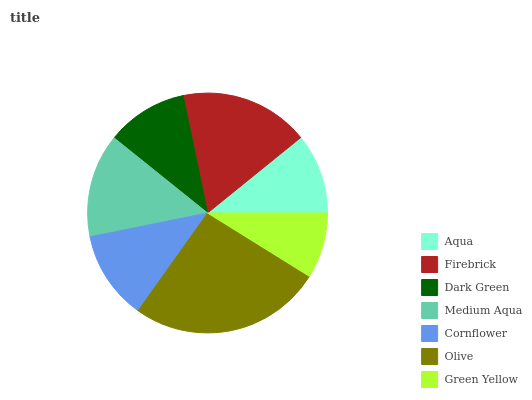Is Green Yellow the minimum?
Answer yes or no. Yes. Is Olive the maximum?
Answer yes or no. Yes. Is Firebrick the minimum?
Answer yes or no. No. Is Firebrick the maximum?
Answer yes or no. No. Is Firebrick greater than Aqua?
Answer yes or no. Yes. Is Aqua less than Firebrick?
Answer yes or no. Yes. Is Aqua greater than Firebrick?
Answer yes or no. No. Is Firebrick less than Aqua?
Answer yes or no. No. Is Cornflower the high median?
Answer yes or no. Yes. Is Cornflower the low median?
Answer yes or no. Yes. Is Green Yellow the high median?
Answer yes or no. No. Is Aqua the low median?
Answer yes or no. No. 